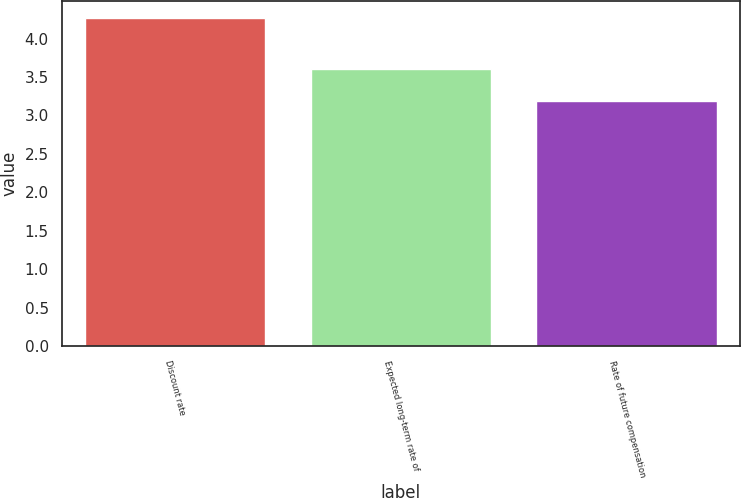Convert chart to OTSL. <chart><loc_0><loc_0><loc_500><loc_500><bar_chart><fcel>Discount rate<fcel>Expected long-term rate of<fcel>Rate of future compensation<nl><fcel>4.27<fcel>3.61<fcel>3.19<nl></chart> 